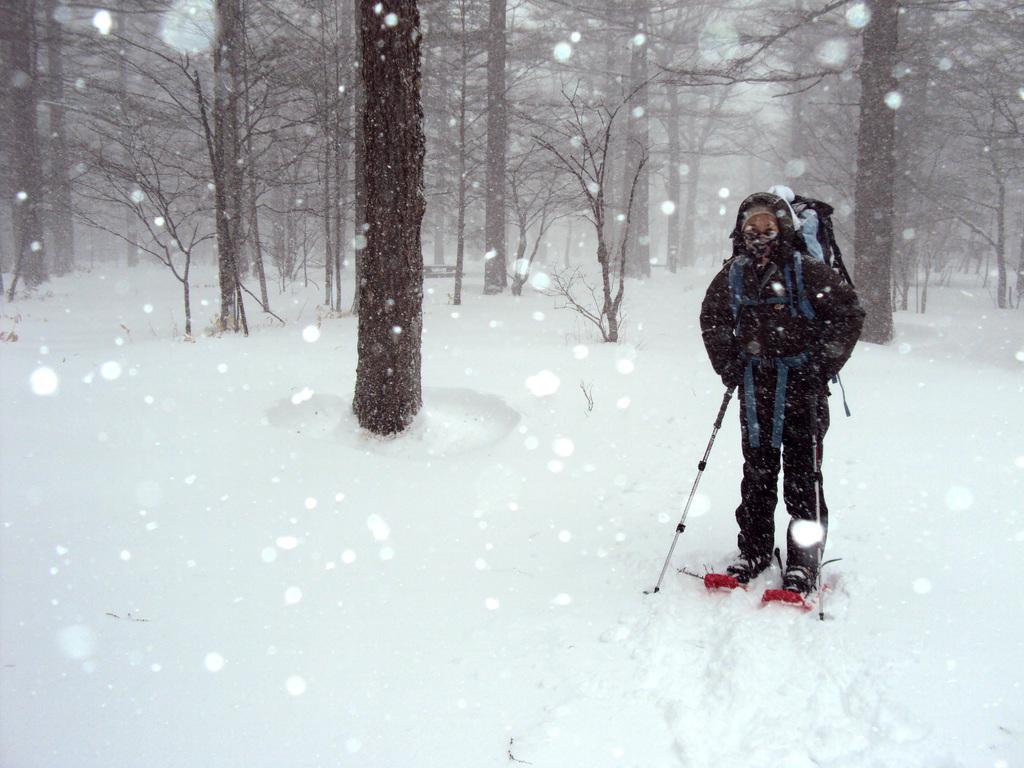Who or what is in the image? There is a person in the image. What is the person wearing? The person is wearing skiing gear. Where is the person located? The person is standing on the surface of the snow. What can be seen in the background of the image? There are trees visible in the background of the image. What historical event is taking place in the image? There is no historical event taking place in the image; it simply shows a person wearing skiing gear and standing on snow with trees in the background. 